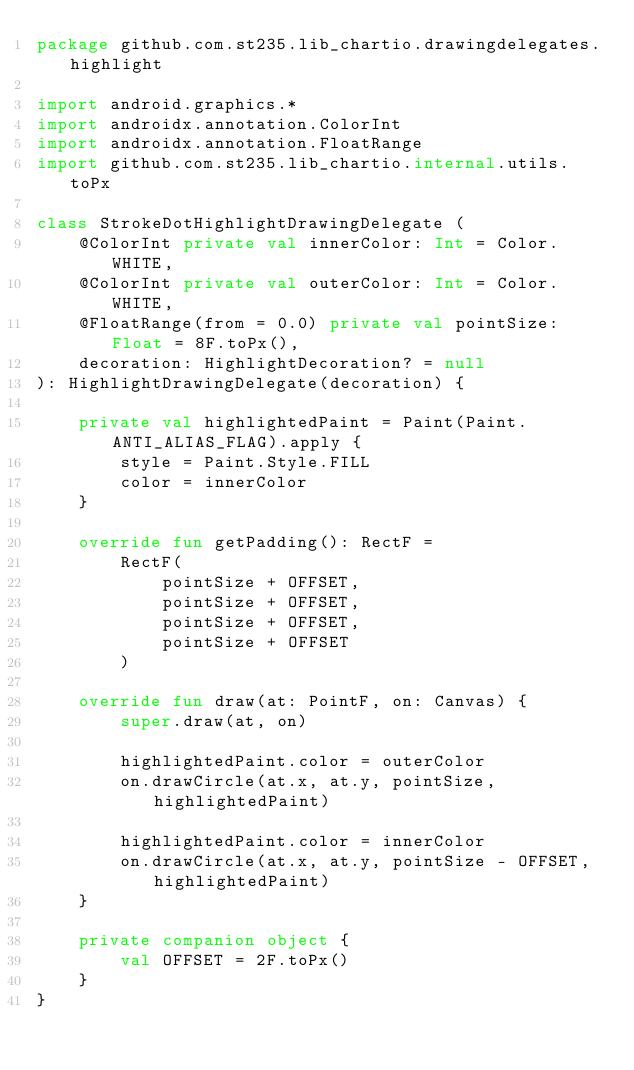Convert code to text. <code><loc_0><loc_0><loc_500><loc_500><_Kotlin_>package github.com.st235.lib_chartio.drawingdelegates.highlight

import android.graphics.*
import androidx.annotation.ColorInt
import androidx.annotation.FloatRange
import github.com.st235.lib_chartio.internal.utils.toPx

class StrokeDotHighlightDrawingDelegate (
    @ColorInt private val innerColor: Int = Color.WHITE,
    @ColorInt private val outerColor: Int = Color.WHITE,
    @FloatRange(from = 0.0) private val pointSize: Float = 8F.toPx(),
    decoration: HighlightDecoration? = null
): HighlightDrawingDelegate(decoration) {

    private val highlightedPaint = Paint(Paint.ANTI_ALIAS_FLAG).apply {
        style = Paint.Style.FILL
        color = innerColor
    }

    override fun getPadding(): RectF =
        RectF(
            pointSize + OFFSET,
            pointSize + OFFSET,
            pointSize + OFFSET,
            pointSize + OFFSET
        )

    override fun draw(at: PointF, on: Canvas) {
        super.draw(at, on)

        highlightedPaint.color = outerColor
        on.drawCircle(at.x, at.y, pointSize, highlightedPaint)

        highlightedPaint.color = innerColor
        on.drawCircle(at.x, at.y, pointSize - OFFSET, highlightedPaint)
    }

    private companion object {
        val OFFSET = 2F.toPx()
    }
}</code> 